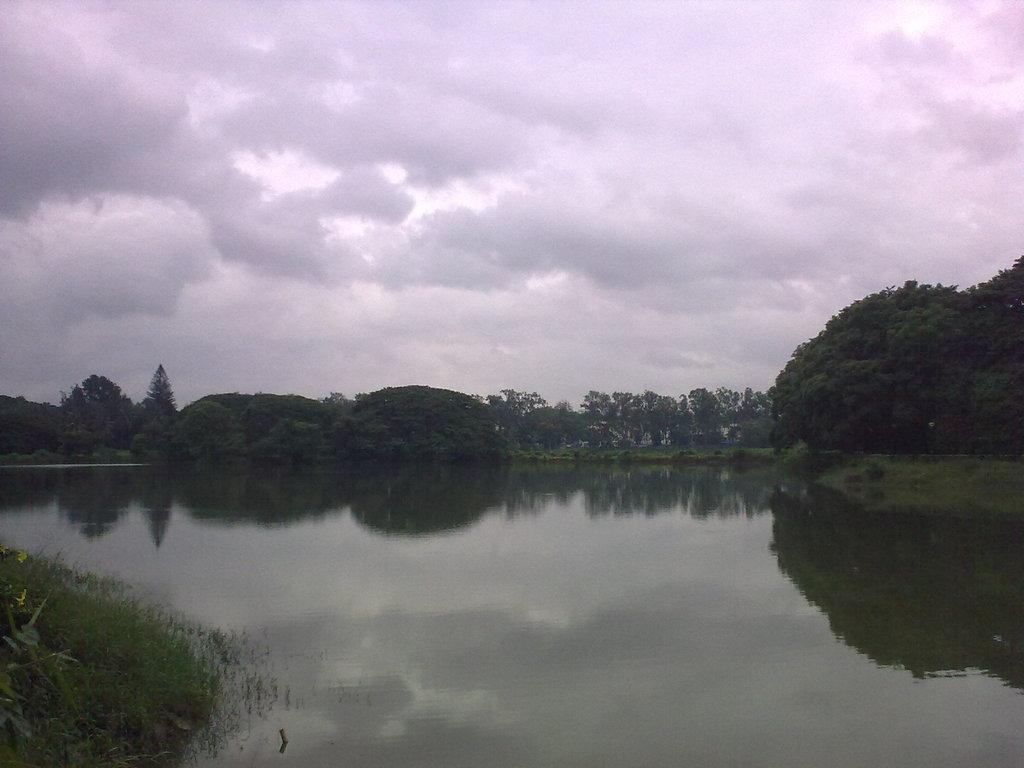What is one of the natural elements present in the image? There is water in the image. What type of vegetation can be seen in the image? There is grass and trees in the image. What is the color of the trees in the image? The trees are green in color. What can be seen in the background of the image? The sky is visible in the background of the image. What type of gold jewelry is the tree wearing in the image? There is no gold jewelry or any indication of jewelry present in the image. 